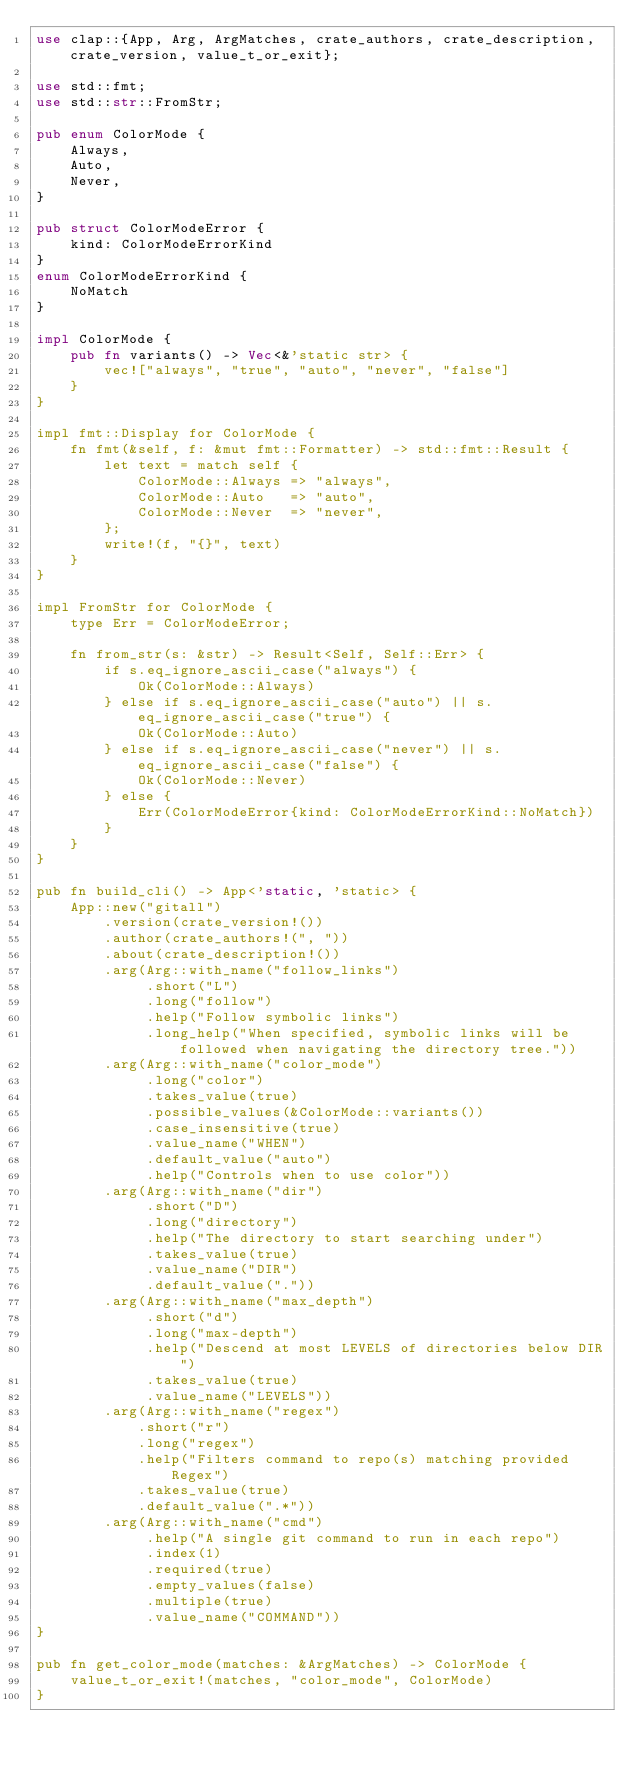Convert code to text. <code><loc_0><loc_0><loc_500><loc_500><_Rust_>use clap::{App, Arg, ArgMatches, crate_authors, crate_description, crate_version, value_t_or_exit};

use std::fmt;
use std::str::FromStr;

pub enum ColorMode {
    Always,
    Auto,
    Never,
}

pub struct ColorModeError {
    kind: ColorModeErrorKind
}
enum ColorModeErrorKind {
    NoMatch
}

impl ColorMode {
    pub fn variants() -> Vec<&'static str> {
        vec!["always", "true", "auto", "never", "false"]
    }
}

impl fmt::Display for ColorMode {
    fn fmt(&self, f: &mut fmt::Formatter) -> std::fmt::Result {
        let text = match self {
            ColorMode::Always => "always",
            ColorMode::Auto   => "auto",
            ColorMode::Never  => "never",
        };
        write!(f, "{}", text)
    }
}

impl FromStr for ColorMode {
    type Err = ColorModeError;

    fn from_str(s: &str) -> Result<Self, Self::Err> {
        if s.eq_ignore_ascii_case("always") {
            Ok(ColorMode::Always)
        } else if s.eq_ignore_ascii_case("auto") || s.eq_ignore_ascii_case("true") {
            Ok(ColorMode::Auto)
        } else if s.eq_ignore_ascii_case("never") || s.eq_ignore_ascii_case("false") {
            Ok(ColorMode::Never)
        } else {
            Err(ColorModeError{kind: ColorModeErrorKind::NoMatch})
        }
    }
}

pub fn build_cli() -> App<'static, 'static> {
    App::new("gitall")
        .version(crate_version!())
        .author(crate_authors!(", "))
        .about(crate_description!())
        .arg(Arg::with_name("follow_links")
             .short("L")
             .long("follow")
             .help("Follow symbolic links")
             .long_help("When specified, symbolic links will be followed when navigating the directory tree."))
        .arg(Arg::with_name("color_mode")
             .long("color")
             .takes_value(true)
             .possible_values(&ColorMode::variants())
             .case_insensitive(true)
             .value_name("WHEN")
             .default_value("auto")
             .help("Controls when to use color"))
        .arg(Arg::with_name("dir")
             .short("D")
             .long("directory")
             .help("The directory to start searching under")
             .takes_value(true)
             .value_name("DIR")
             .default_value("."))
        .arg(Arg::with_name("max_depth")
             .short("d")
             .long("max-depth")
             .help("Descend at most LEVELS of directories below DIR")
             .takes_value(true)
             .value_name("LEVELS"))
        .arg(Arg::with_name("regex")
            .short("r")
            .long("regex")
            .help("Filters command to repo(s) matching provided Regex")
            .takes_value(true)
            .default_value(".*"))
        .arg(Arg::with_name("cmd")
             .help("A single git command to run in each repo")
             .index(1)
             .required(true)
             .empty_values(false)
             .multiple(true)
             .value_name("COMMAND"))
}

pub fn get_color_mode(matches: &ArgMatches) -> ColorMode {
    value_t_or_exit!(matches, "color_mode", ColorMode)
}
</code> 